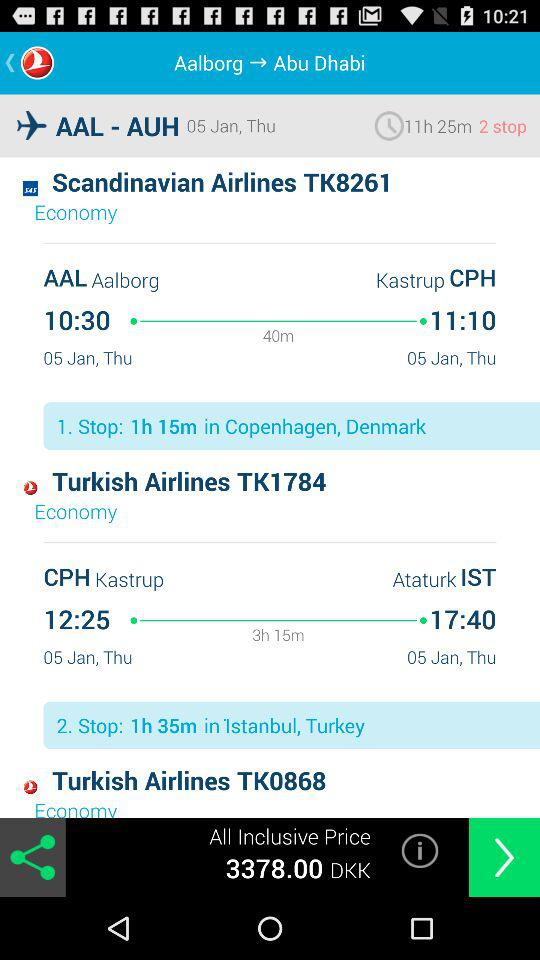What is the departure time of "Turkish Airlines TK1784"? The departure time is 12:25. 